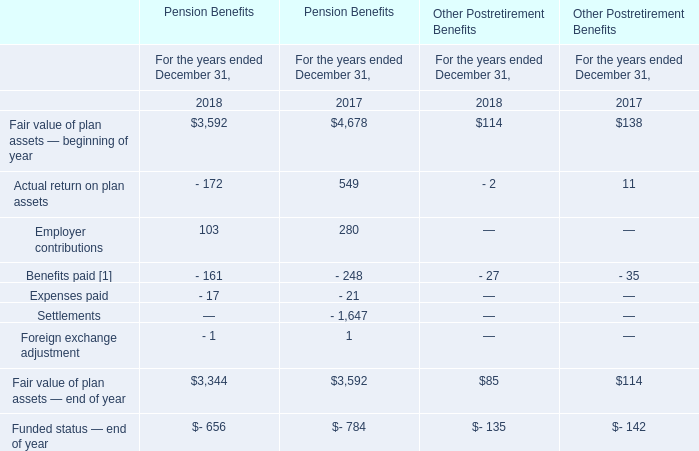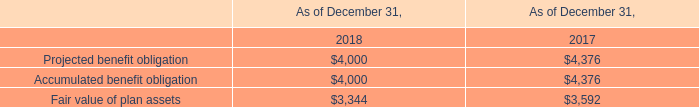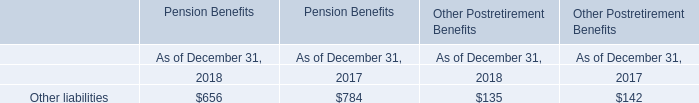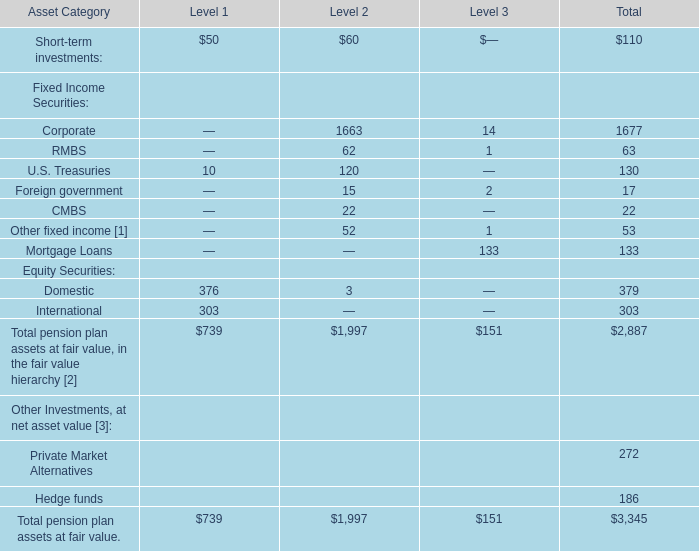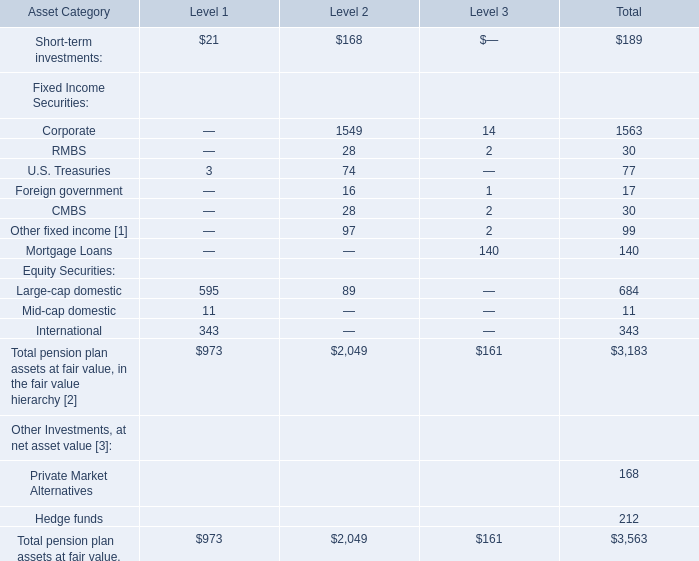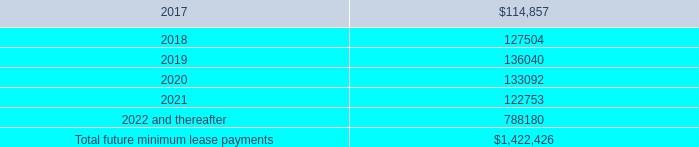what was the percentage change in rent expenses included in selling , general and administrative expense from 2014 to 2015? 
Computations: ((83.0 - 59.0) / 59.0)
Answer: 0.40678. 